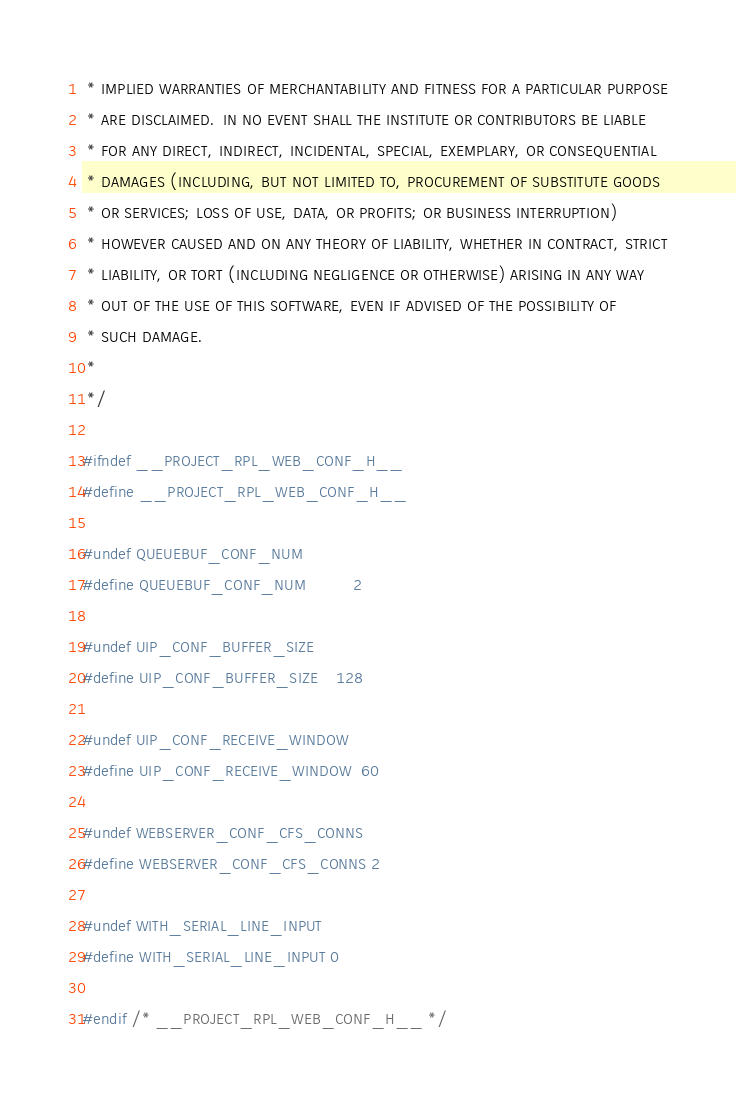Convert code to text. <code><loc_0><loc_0><loc_500><loc_500><_C_> * IMPLIED WARRANTIES OF MERCHANTABILITY AND FITNESS FOR A PARTICULAR PURPOSE
 * ARE DISCLAIMED.  IN NO EVENT SHALL THE INSTITUTE OR CONTRIBUTORS BE LIABLE
 * FOR ANY DIRECT, INDIRECT, INCIDENTAL, SPECIAL, EXEMPLARY, OR CONSEQUENTIAL
 * DAMAGES (INCLUDING, BUT NOT LIMITED TO, PROCUREMENT OF SUBSTITUTE GOODS
 * OR SERVICES; LOSS OF USE, DATA, OR PROFITS; OR BUSINESS INTERRUPTION)
 * HOWEVER CAUSED AND ON ANY THEORY OF LIABILITY, WHETHER IN CONTRACT, STRICT
 * LIABILITY, OR TORT (INCLUDING NEGLIGENCE OR OTHERWISE) ARISING IN ANY WAY
 * OUT OF THE USE OF THIS SOFTWARE, EVEN IF ADVISED OF THE POSSIBILITY OF
 * SUCH DAMAGE.
 *
 */

#ifndef __PROJECT_RPL_WEB_CONF_H__
#define __PROJECT_RPL_WEB_CONF_H__

#undef QUEUEBUF_CONF_NUM
#define QUEUEBUF_CONF_NUM          2

#undef UIP_CONF_BUFFER_SIZE
#define UIP_CONF_BUFFER_SIZE    128

#undef UIP_CONF_RECEIVE_WINDOW
#define UIP_CONF_RECEIVE_WINDOW  60

#undef WEBSERVER_CONF_CFS_CONNS
#define WEBSERVER_CONF_CFS_CONNS 2

#undef WITH_SERIAL_LINE_INPUT
#define WITH_SERIAL_LINE_INPUT 0

#endif /* __PROJECT_RPL_WEB_CONF_H__ */
</code> 